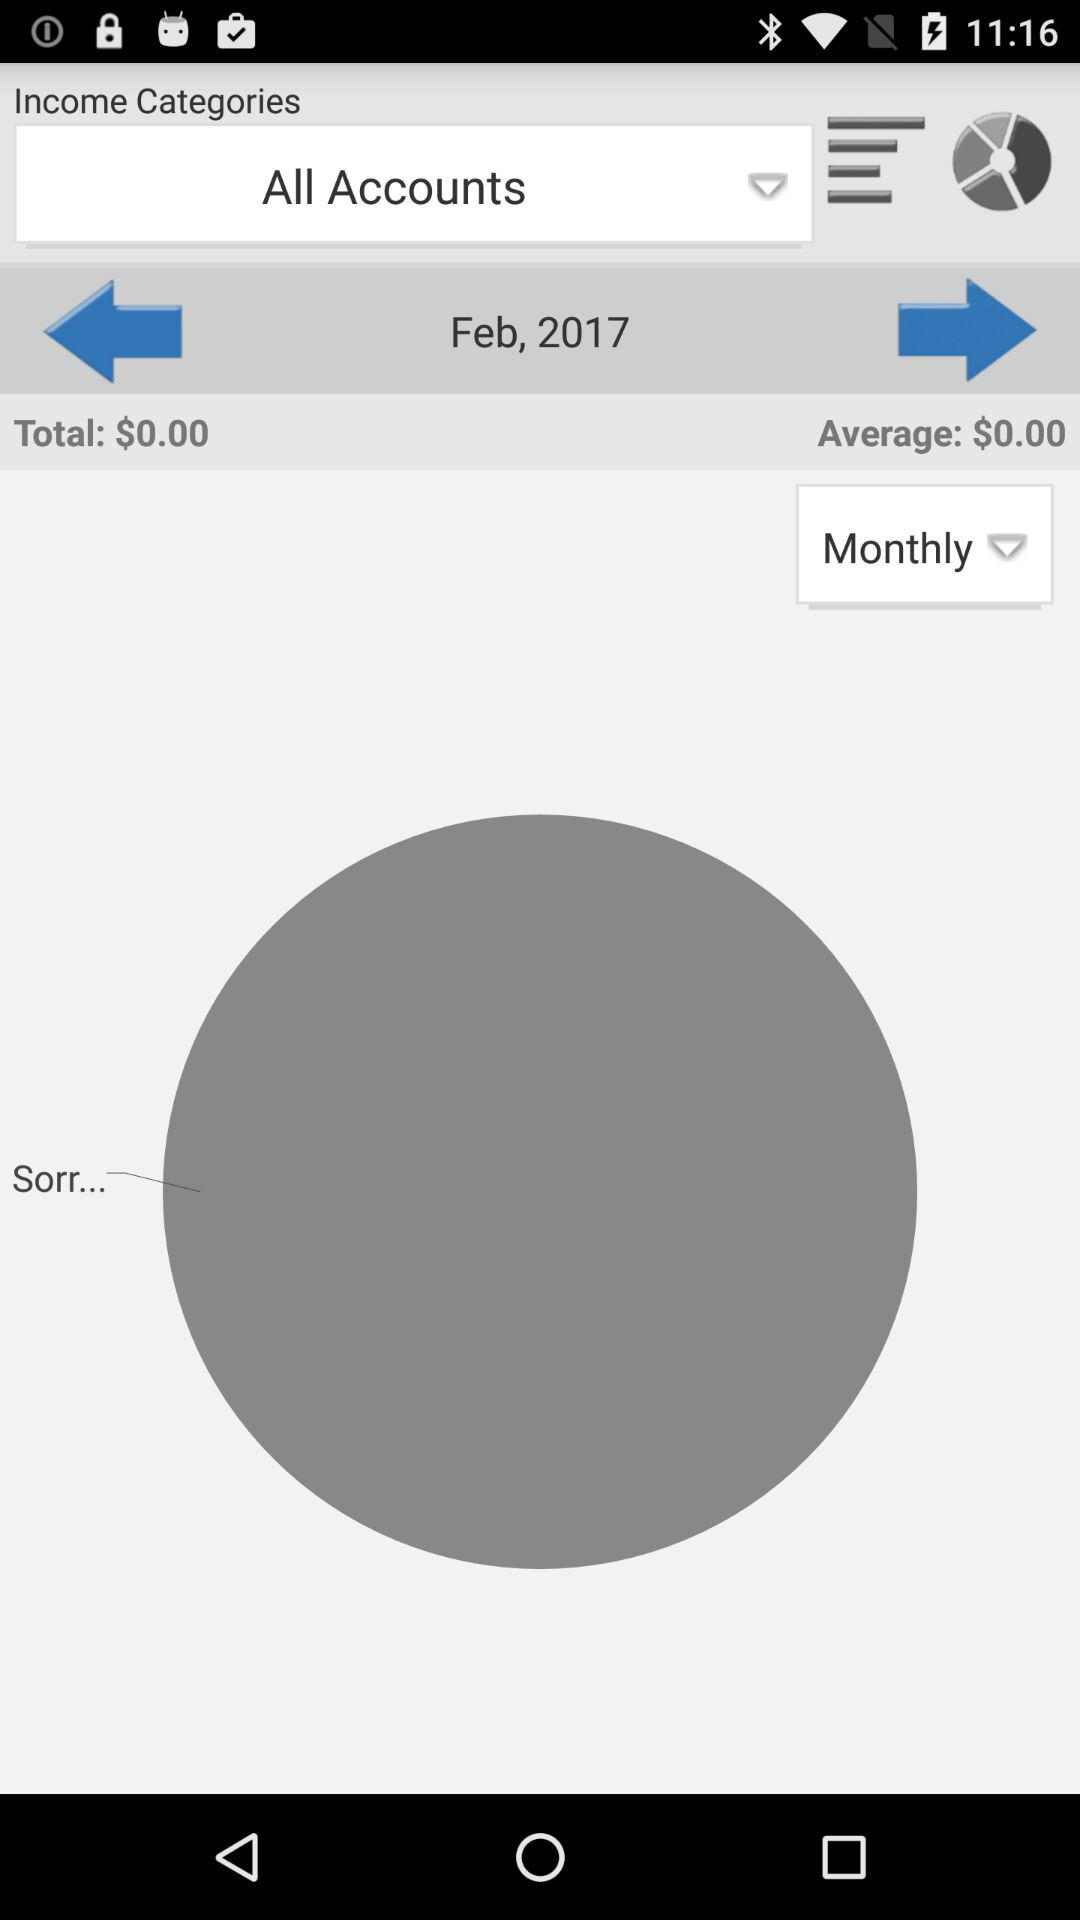What is the total amount? The total amount is $0.00. 